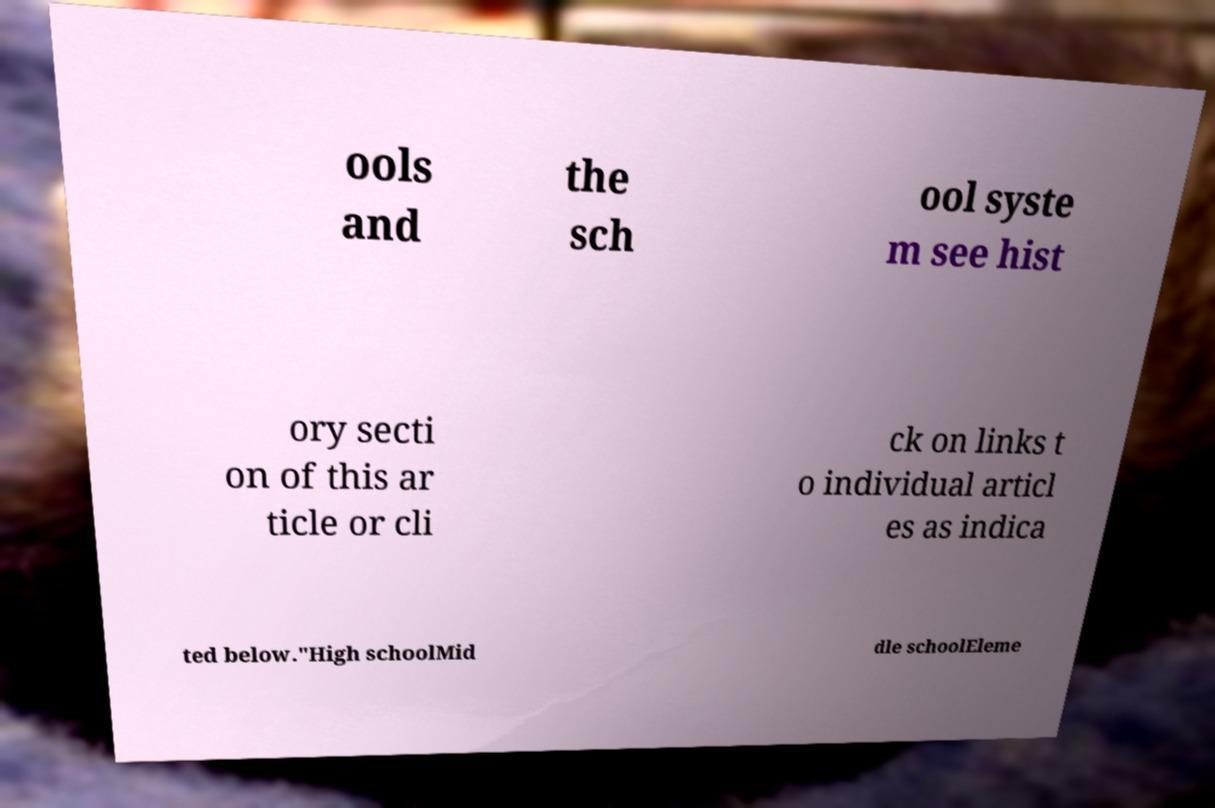For documentation purposes, I need the text within this image transcribed. Could you provide that? ools and the sch ool syste m see hist ory secti on of this ar ticle or cli ck on links t o individual articl es as indica ted below."High schoolMid dle schoolEleme 